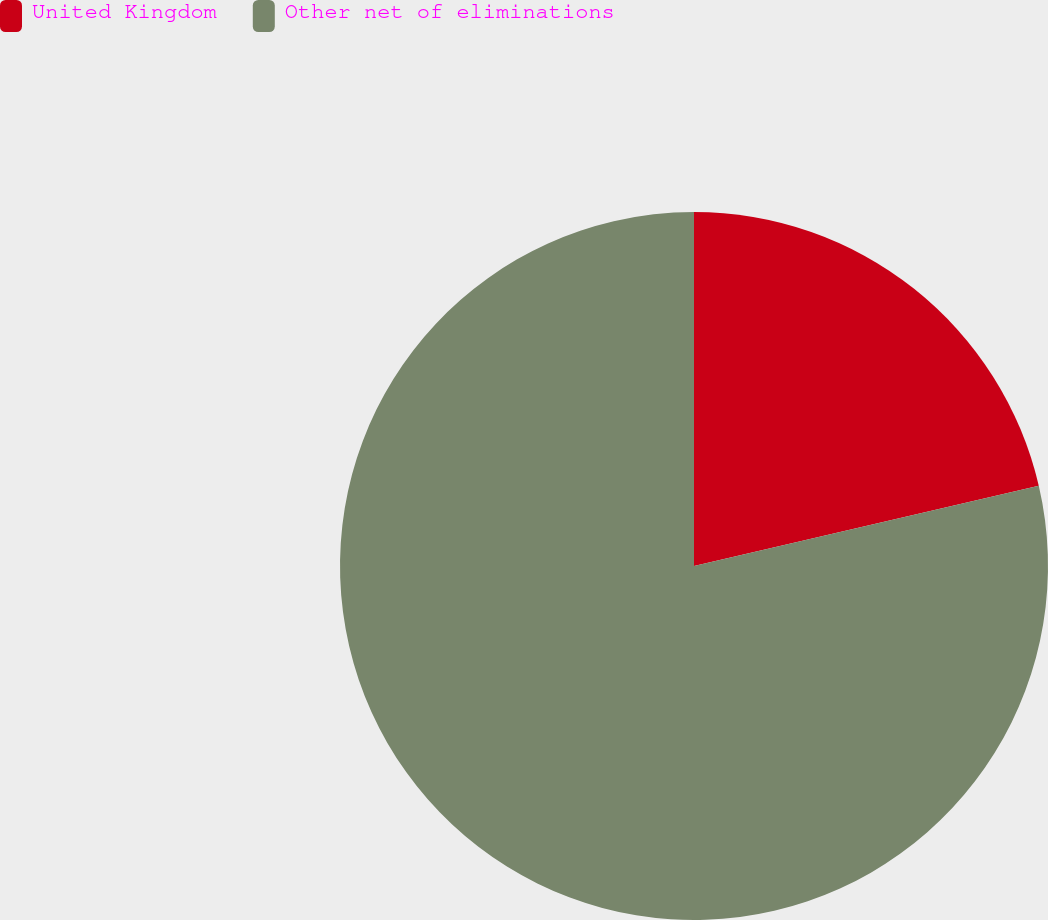Convert chart. <chart><loc_0><loc_0><loc_500><loc_500><pie_chart><fcel>United Kingdom<fcel>Other net of eliminations<nl><fcel>21.36%<fcel>78.64%<nl></chart> 